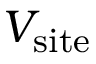<formula> <loc_0><loc_0><loc_500><loc_500>V _ { s i t e }</formula> 